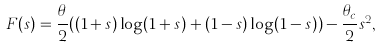<formula> <loc_0><loc_0><loc_500><loc_500>& F ( s ) = \frac { \theta } { 2 } ( ( 1 + s ) \log ( 1 + s ) + ( 1 - s ) \log ( 1 - s ) ) - \frac { \theta _ { c } } { 2 } s ^ { 2 } ,</formula> 